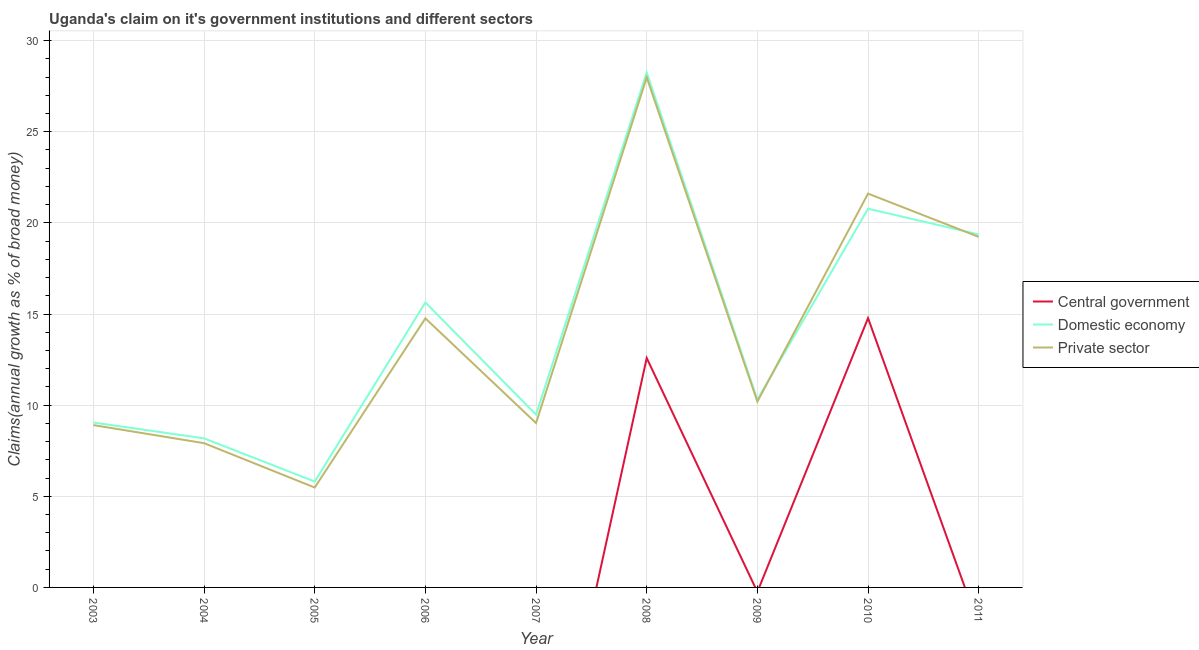Does the line corresponding to percentage of claim on the central government intersect with the line corresponding to percentage of claim on the private sector?
Your answer should be very brief. No. Is the number of lines equal to the number of legend labels?
Keep it short and to the point. No. What is the percentage of claim on the central government in 2005?
Ensure brevity in your answer.  0. Across all years, what is the maximum percentage of claim on the private sector?
Make the answer very short. 27.98. What is the total percentage of claim on the private sector in the graph?
Provide a short and direct response. 125.1. What is the difference between the percentage of claim on the domestic economy in 2007 and that in 2009?
Offer a terse response. -0.82. What is the difference between the percentage of claim on the domestic economy in 2007 and the percentage of claim on the central government in 2008?
Offer a very short reply. -3.1. What is the average percentage of claim on the private sector per year?
Offer a very short reply. 13.9. In the year 2003, what is the difference between the percentage of claim on the private sector and percentage of claim on the domestic economy?
Ensure brevity in your answer.  -0.14. In how many years, is the percentage of claim on the domestic economy greater than 7 %?
Provide a short and direct response. 8. What is the ratio of the percentage of claim on the private sector in 2004 to that in 2009?
Provide a short and direct response. 0.78. Is the percentage of claim on the private sector in 2003 less than that in 2011?
Offer a very short reply. Yes. Is the difference between the percentage of claim on the private sector in 2005 and 2008 greater than the difference between the percentage of claim on the domestic economy in 2005 and 2008?
Your response must be concise. No. What is the difference between the highest and the second highest percentage of claim on the private sector?
Provide a succinct answer. 6.38. What is the difference between the highest and the lowest percentage of claim on the domestic economy?
Give a very brief answer. 22.44. Is the sum of the percentage of claim on the domestic economy in 2005 and 2008 greater than the maximum percentage of claim on the central government across all years?
Provide a short and direct response. Yes. Does the percentage of claim on the private sector monotonically increase over the years?
Offer a terse response. No. Is the percentage of claim on the domestic economy strictly greater than the percentage of claim on the private sector over the years?
Offer a very short reply. No. Is the percentage of claim on the private sector strictly less than the percentage of claim on the domestic economy over the years?
Provide a succinct answer. No. How many lines are there?
Keep it short and to the point. 3. How many years are there in the graph?
Provide a short and direct response. 9. How are the legend labels stacked?
Give a very brief answer. Vertical. What is the title of the graph?
Provide a succinct answer. Uganda's claim on it's government institutions and different sectors. Does "Poland" appear as one of the legend labels in the graph?
Your response must be concise. No. What is the label or title of the X-axis?
Make the answer very short. Year. What is the label or title of the Y-axis?
Offer a terse response. Claims(annual growth as % of broad money). What is the Claims(annual growth as % of broad money) of Central government in 2003?
Your response must be concise. 0. What is the Claims(annual growth as % of broad money) of Domestic economy in 2003?
Provide a succinct answer. 9.05. What is the Claims(annual growth as % of broad money) in Private sector in 2003?
Give a very brief answer. 8.91. What is the Claims(annual growth as % of broad money) in Central government in 2004?
Make the answer very short. 0. What is the Claims(annual growth as % of broad money) of Domestic economy in 2004?
Offer a terse response. 8.18. What is the Claims(annual growth as % of broad money) of Private sector in 2004?
Provide a short and direct response. 7.91. What is the Claims(annual growth as % of broad money) in Central government in 2005?
Your answer should be compact. 0. What is the Claims(annual growth as % of broad money) in Domestic economy in 2005?
Your answer should be very brief. 5.81. What is the Claims(annual growth as % of broad money) of Private sector in 2005?
Give a very brief answer. 5.48. What is the Claims(annual growth as % of broad money) of Domestic economy in 2006?
Offer a terse response. 15.63. What is the Claims(annual growth as % of broad money) of Private sector in 2006?
Give a very brief answer. 14.76. What is the Claims(annual growth as % of broad money) of Domestic economy in 2007?
Give a very brief answer. 9.48. What is the Claims(annual growth as % of broad money) of Private sector in 2007?
Make the answer very short. 9.02. What is the Claims(annual growth as % of broad money) of Central government in 2008?
Make the answer very short. 12.59. What is the Claims(annual growth as % of broad money) in Domestic economy in 2008?
Provide a succinct answer. 28.25. What is the Claims(annual growth as % of broad money) in Private sector in 2008?
Give a very brief answer. 27.98. What is the Claims(annual growth as % of broad money) of Domestic economy in 2009?
Your answer should be compact. 10.31. What is the Claims(annual growth as % of broad money) of Private sector in 2009?
Make the answer very short. 10.2. What is the Claims(annual growth as % of broad money) in Central government in 2010?
Your response must be concise. 14.78. What is the Claims(annual growth as % of broad money) in Domestic economy in 2010?
Give a very brief answer. 20.78. What is the Claims(annual growth as % of broad money) in Private sector in 2010?
Your answer should be very brief. 21.61. What is the Claims(annual growth as % of broad money) of Domestic economy in 2011?
Make the answer very short. 19.37. What is the Claims(annual growth as % of broad money) in Private sector in 2011?
Give a very brief answer. 19.23. Across all years, what is the maximum Claims(annual growth as % of broad money) in Central government?
Provide a succinct answer. 14.78. Across all years, what is the maximum Claims(annual growth as % of broad money) in Domestic economy?
Your answer should be compact. 28.25. Across all years, what is the maximum Claims(annual growth as % of broad money) of Private sector?
Offer a very short reply. 27.98. Across all years, what is the minimum Claims(annual growth as % of broad money) in Domestic economy?
Provide a short and direct response. 5.81. Across all years, what is the minimum Claims(annual growth as % of broad money) of Private sector?
Your response must be concise. 5.48. What is the total Claims(annual growth as % of broad money) in Central government in the graph?
Ensure brevity in your answer.  27.36. What is the total Claims(annual growth as % of broad money) of Domestic economy in the graph?
Offer a very short reply. 126.85. What is the total Claims(annual growth as % of broad money) of Private sector in the graph?
Provide a short and direct response. 125.1. What is the difference between the Claims(annual growth as % of broad money) of Domestic economy in 2003 and that in 2004?
Give a very brief answer. 0.87. What is the difference between the Claims(annual growth as % of broad money) in Private sector in 2003 and that in 2004?
Offer a terse response. 0.99. What is the difference between the Claims(annual growth as % of broad money) of Domestic economy in 2003 and that in 2005?
Your answer should be very brief. 3.24. What is the difference between the Claims(annual growth as % of broad money) in Private sector in 2003 and that in 2005?
Provide a short and direct response. 3.43. What is the difference between the Claims(annual growth as % of broad money) of Domestic economy in 2003 and that in 2006?
Your response must be concise. -6.59. What is the difference between the Claims(annual growth as % of broad money) of Private sector in 2003 and that in 2006?
Your answer should be very brief. -5.86. What is the difference between the Claims(annual growth as % of broad money) of Domestic economy in 2003 and that in 2007?
Give a very brief answer. -0.43. What is the difference between the Claims(annual growth as % of broad money) of Private sector in 2003 and that in 2007?
Your answer should be very brief. -0.11. What is the difference between the Claims(annual growth as % of broad money) of Domestic economy in 2003 and that in 2008?
Offer a terse response. -19.2. What is the difference between the Claims(annual growth as % of broad money) of Private sector in 2003 and that in 2008?
Your answer should be very brief. -19.08. What is the difference between the Claims(annual growth as % of broad money) of Domestic economy in 2003 and that in 2009?
Keep it short and to the point. -1.26. What is the difference between the Claims(annual growth as % of broad money) of Private sector in 2003 and that in 2009?
Provide a succinct answer. -1.29. What is the difference between the Claims(annual growth as % of broad money) of Domestic economy in 2003 and that in 2010?
Ensure brevity in your answer.  -11.73. What is the difference between the Claims(annual growth as % of broad money) in Private sector in 2003 and that in 2010?
Keep it short and to the point. -12.7. What is the difference between the Claims(annual growth as % of broad money) of Domestic economy in 2003 and that in 2011?
Provide a short and direct response. -10.32. What is the difference between the Claims(annual growth as % of broad money) of Private sector in 2003 and that in 2011?
Offer a terse response. -10.33. What is the difference between the Claims(annual growth as % of broad money) in Domestic economy in 2004 and that in 2005?
Offer a very short reply. 2.37. What is the difference between the Claims(annual growth as % of broad money) in Private sector in 2004 and that in 2005?
Provide a short and direct response. 2.43. What is the difference between the Claims(annual growth as % of broad money) of Domestic economy in 2004 and that in 2006?
Provide a succinct answer. -7.45. What is the difference between the Claims(annual growth as % of broad money) of Private sector in 2004 and that in 2006?
Your answer should be compact. -6.85. What is the difference between the Claims(annual growth as % of broad money) in Domestic economy in 2004 and that in 2007?
Provide a succinct answer. -1.3. What is the difference between the Claims(annual growth as % of broad money) of Private sector in 2004 and that in 2007?
Give a very brief answer. -1.1. What is the difference between the Claims(annual growth as % of broad money) of Domestic economy in 2004 and that in 2008?
Give a very brief answer. -20.07. What is the difference between the Claims(annual growth as % of broad money) of Private sector in 2004 and that in 2008?
Ensure brevity in your answer.  -20.07. What is the difference between the Claims(annual growth as % of broad money) in Domestic economy in 2004 and that in 2009?
Your response must be concise. -2.13. What is the difference between the Claims(annual growth as % of broad money) of Private sector in 2004 and that in 2009?
Give a very brief answer. -2.28. What is the difference between the Claims(annual growth as % of broad money) in Domestic economy in 2004 and that in 2010?
Keep it short and to the point. -12.6. What is the difference between the Claims(annual growth as % of broad money) in Private sector in 2004 and that in 2010?
Keep it short and to the point. -13.69. What is the difference between the Claims(annual growth as % of broad money) in Domestic economy in 2004 and that in 2011?
Your answer should be very brief. -11.19. What is the difference between the Claims(annual growth as % of broad money) in Private sector in 2004 and that in 2011?
Make the answer very short. -11.32. What is the difference between the Claims(annual growth as % of broad money) in Domestic economy in 2005 and that in 2006?
Provide a short and direct response. -9.82. What is the difference between the Claims(annual growth as % of broad money) of Private sector in 2005 and that in 2006?
Ensure brevity in your answer.  -9.28. What is the difference between the Claims(annual growth as % of broad money) of Domestic economy in 2005 and that in 2007?
Offer a terse response. -3.67. What is the difference between the Claims(annual growth as % of broad money) in Private sector in 2005 and that in 2007?
Make the answer very short. -3.54. What is the difference between the Claims(annual growth as % of broad money) in Domestic economy in 2005 and that in 2008?
Your response must be concise. -22.44. What is the difference between the Claims(annual growth as % of broad money) in Private sector in 2005 and that in 2008?
Offer a terse response. -22.5. What is the difference between the Claims(annual growth as % of broad money) of Domestic economy in 2005 and that in 2009?
Ensure brevity in your answer.  -4.5. What is the difference between the Claims(annual growth as % of broad money) of Private sector in 2005 and that in 2009?
Your response must be concise. -4.71. What is the difference between the Claims(annual growth as % of broad money) in Domestic economy in 2005 and that in 2010?
Ensure brevity in your answer.  -14.97. What is the difference between the Claims(annual growth as % of broad money) in Private sector in 2005 and that in 2010?
Provide a succinct answer. -16.13. What is the difference between the Claims(annual growth as % of broad money) of Domestic economy in 2005 and that in 2011?
Provide a short and direct response. -13.56. What is the difference between the Claims(annual growth as % of broad money) of Private sector in 2005 and that in 2011?
Give a very brief answer. -13.75. What is the difference between the Claims(annual growth as % of broad money) in Domestic economy in 2006 and that in 2007?
Ensure brevity in your answer.  6.15. What is the difference between the Claims(annual growth as % of broad money) of Private sector in 2006 and that in 2007?
Your response must be concise. 5.75. What is the difference between the Claims(annual growth as % of broad money) in Domestic economy in 2006 and that in 2008?
Make the answer very short. -12.61. What is the difference between the Claims(annual growth as % of broad money) of Private sector in 2006 and that in 2008?
Give a very brief answer. -13.22. What is the difference between the Claims(annual growth as % of broad money) in Domestic economy in 2006 and that in 2009?
Provide a short and direct response. 5.33. What is the difference between the Claims(annual growth as % of broad money) in Private sector in 2006 and that in 2009?
Offer a terse response. 4.57. What is the difference between the Claims(annual growth as % of broad money) of Domestic economy in 2006 and that in 2010?
Give a very brief answer. -5.14. What is the difference between the Claims(annual growth as % of broad money) in Private sector in 2006 and that in 2010?
Offer a terse response. -6.84. What is the difference between the Claims(annual growth as % of broad money) in Domestic economy in 2006 and that in 2011?
Provide a succinct answer. -3.73. What is the difference between the Claims(annual growth as % of broad money) of Private sector in 2006 and that in 2011?
Keep it short and to the point. -4.47. What is the difference between the Claims(annual growth as % of broad money) of Domestic economy in 2007 and that in 2008?
Ensure brevity in your answer.  -18.76. What is the difference between the Claims(annual growth as % of broad money) of Private sector in 2007 and that in 2008?
Offer a very short reply. -18.97. What is the difference between the Claims(annual growth as % of broad money) in Domestic economy in 2007 and that in 2009?
Your response must be concise. -0.82. What is the difference between the Claims(annual growth as % of broad money) of Private sector in 2007 and that in 2009?
Your answer should be compact. -1.18. What is the difference between the Claims(annual growth as % of broad money) in Domestic economy in 2007 and that in 2010?
Your answer should be very brief. -11.3. What is the difference between the Claims(annual growth as % of broad money) in Private sector in 2007 and that in 2010?
Ensure brevity in your answer.  -12.59. What is the difference between the Claims(annual growth as % of broad money) of Domestic economy in 2007 and that in 2011?
Your answer should be compact. -9.89. What is the difference between the Claims(annual growth as % of broad money) in Private sector in 2007 and that in 2011?
Provide a succinct answer. -10.22. What is the difference between the Claims(annual growth as % of broad money) of Domestic economy in 2008 and that in 2009?
Keep it short and to the point. 17.94. What is the difference between the Claims(annual growth as % of broad money) of Private sector in 2008 and that in 2009?
Offer a very short reply. 17.79. What is the difference between the Claims(annual growth as % of broad money) in Central government in 2008 and that in 2010?
Your response must be concise. -2.19. What is the difference between the Claims(annual growth as % of broad money) in Domestic economy in 2008 and that in 2010?
Give a very brief answer. 7.47. What is the difference between the Claims(annual growth as % of broad money) of Private sector in 2008 and that in 2010?
Provide a short and direct response. 6.38. What is the difference between the Claims(annual growth as % of broad money) of Domestic economy in 2008 and that in 2011?
Your response must be concise. 8.88. What is the difference between the Claims(annual growth as % of broad money) in Private sector in 2008 and that in 2011?
Keep it short and to the point. 8.75. What is the difference between the Claims(annual growth as % of broad money) of Domestic economy in 2009 and that in 2010?
Your answer should be very brief. -10.47. What is the difference between the Claims(annual growth as % of broad money) in Private sector in 2009 and that in 2010?
Ensure brevity in your answer.  -11.41. What is the difference between the Claims(annual growth as % of broad money) of Domestic economy in 2009 and that in 2011?
Give a very brief answer. -9.06. What is the difference between the Claims(annual growth as % of broad money) in Private sector in 2009 and that in 2011?
Give a very brief answer. -9.04. What is the difference between the Claims(annual growth as % of broad money) in Domestic economy in 2010 and that in 2011?
Provide a succinct answer. 1.41. What is the difference between the Claims(annual growth as % of broad money) of Private sector in 2010 and that in 2011?
Your answer should be very brief. 2.37. What is the difference between the Claims(annual growth as % of broad money) of Domestic economy in 2003 and the Claims(annual growth as % of broad money) of Private sector in 2004?
Give a very brief answer. 1.13. What is the difference between the Claims(annual growth as % of broad money) in Domestic economy in 2003 and the Claims(annual growth as % of broad money) in Private sector in 2005?
Offer a terse response. 3.57. What is the difference between the Claims(annual growth as % of broad money) in Domestic economy in 2003 and the Claims(annual growth as % of broad money) in Private sector in 2006?
Offer a terse response. -5.72. What is the difference between the Claims(annual growth as % of broad money) of Domestic economy in 2003 and the Claims(annual growth as % of broad money) of Private sector in 2007?
Provide a succinct answer. 0.03. What is the difference between the Claims(annual growth as % of broad money) of Domestic economy in 2003 and the Claims(annual growth as % of broad money) of Private sector in 2008?
Offer a very short reply. -18.94. What is the difference between the Claims(annual growth as % of broad money) of Domestic economy in 2003 and the Claims(annual growth as % of broad money) of Private sector in 2009?
Offer a very short reply. -1.15. What is the difference between the Claims(annual growth as % of broad money) of Domestic economy in 2003 and the Claims(annual growth as % of broad money) of Private sector in 2010?
Provide a short and direct response. -12.56. What is the difference between the Claims(annual growth as % of broad money) in Domestic economy in 2003 and the Claims(annual growth as % of broad money) in Private sector in 2011?
Ensure brevity in your answer.  -10.19. What is the difference between the Claims(annual growth as % of broad money) of Domestic economy in 2004 and the Claims(annual growth as % of broad money) of Private sector in 2005?
Your answer should be very brief. 2.7. What is the difference between the Claims(annual growth as % of broad money) of Domestic economy in 2004 and the Claims(annual growth as % of broad money) of Private sector in 2006?
Your answer should be compact. -6.58. What is the difference between the Claims(annual growth as % of broad money) of Domestic economy in 2004 and the Claims(annual growth as % of broad money) of Private sector in 2007?
Your answer should be very brief. -0.84. What is the difference between the Claims(annual growth as % of broad money) in Domestic economy in 2004 and the Claims(annual growth as % of broad money) in Private sector in 2008?
Your answer should be very brief. -19.8. What is the difference between the Claims(annual growth as % of broad money) in Domestic economy in 2004 and the Claims(annual growth as % of broad money) in Private sector in 2009?
Your response must be concise. -2.01. What is the difference between the Claims(annual growth as % of broad money) of Domestic economy in 2004 and the Claims(annual growth as % of broad money) of Private sector in 2010?
Your answer should be compact. -13.43. What is the difference between the Claims(annual growth as % of broad money) in Domestic economy in 2004 and the Claims(annual growth as % of broad money) in Private sector in 2011?
Your answer should be compact. -11.05. What is the difference between the Claims(annual growth as % of broad money) of Domestic economy in 2005 and the Claims(annual growth as % of broad money) of Private sector in 2006?
Offer a very short reply. -8.95. What is the difference between the Claims(annual growth as % of broad money) in Domestic economy in 2005 and the Claims(annual growth as % of broad money) in Private sector in 2007?
Give a very brief answer. -3.21. What is the difference between the Claims(annual growth as % of broad money) in Domestic economy in 2005 and the Claims(annual growth as % of broad money) in Private sector in 2008?
Make the answer very short. -22.17. What is the difference between the Claims(annual growth as % of broad money) of Domestic economy in 2005 and the Claims(annual growth as % of broad money) of Private sector in 2009?
Your response must be concise. -4.38. What is the difference between the Claims(annual growth as % of broad money) of Domestic economy in 2005 and the Claims(annual growth as % of broad money) of Private sector in 2010?
Keep it short and to the point. -15.8. What is the difference between the Claims(annual growth as % of broad money) of Domestic economy in 2005 and the Claims(annual growth as % of broad money) of Private sector in 2011?
Your response must be concise. -13.42. What is the difference between the Claims(annual growth as % of broad money) of Domestic economy in 2006 and the Claims(annual growth as % of broad money) of Private sector in 2007?
Offer a very short reply. 6.62. What is the difference between the Claims(annual growth as % of broad money) of Domestic economy in 2006 and the Claims(annual growth as % of broad money) of Private sector in 2008?
Keep it short and to the point. -12.35. What is the difference between the Claims(annual growth as % of broad money) in Domestic economy in 2006 and the Claims(annual growth as % of broad money) in Private sector in 2009?
Keep it short and to the point. 5.44. What is the difference between the Claims(annual growth as % of broad money) in Domestic economy in 2006 and the Claims(annual growth as % of broad money) in Private sector in 2010?
Offer a very short reply. -5.97. What is the difference between the Claims(annual growth as % of broad money) in Domestic economy in 2006 and the Claims(annual growth as % of broad money) in Private sector in 2011?
Offer a terse response. -3.6. What is the difference between the Claims(annual growth as % of broad money) in Domestic economy in 2007 and the Claims(annual growth as % of broad money) in Private sector in 2008?
Offer a terse response. -18.5. What is the difference between the Claims(annual growth as % of broad money) of Domestic economy in 2007 and the Claims(annual growth as % of broad money) of Private sector in 2009?
Offer a terse response. -0.71. What is the difference between the Claims(annual growth as % of broad money) in Domestic economy in 2007 and the Claims(annual growth as % of broad money) in Private sector in 2010?
Provide a short and direct response. -12.13. What is the difference between the Claims(annual growth as % of broad money) in Domestic economy in 2007 and the Claims(annual growth as % of broad money) in Private sector in 2011?
Give a very brief answer. -9.75. What is the difference between the Claims(annual growth as % of broad money) in Central government in 2008 and the Claims(annual growth as % of broad money) in Domestic economy in 2009?
Your response must be concise. 2.28. What is the difference between the Claims(annual growth as % of broad money) in Central government in 2008 and the Claims(annual growth as % of broad money) in Private sector in 2009?
Offer a very short reply. 2.39. What is the difference between the Claims(annual growth as % of broad money) in Domestic economy in 2008 and the Claims(annual growth as % of broad money) in Private sector in 2009?
Provide a short and direct response. 18.05. What is the difference between the Claims(annual growth as % of broad money) of Central government in 2008 and the Claims(annual growth as % of broad money) of Domestic economy in 2010?
Provide a short and direct response. -8.19. What is the difference between the Claims(annual growth as % of broad money) in Central government in 2008 and the Claims(annual growth as % of broad money) in Private sector in 2010?
Your answer should be very brief. -9.02. What is the difference between the Claims(annual growth as % of broad money) in Domestic economy in 2008 and the Claims(annual growth as % of broad money) in Private sector in 2010?
Make the answer very short. 6.64. What is the difference between the Claims(annual growth as % of broad money) in Central government in 2008 and the Claims(annual growth as % of broad money) in Domestic economy in 2011?
Give a very brief answer. -6.78. What is the difference between the Claims(annual growth as % of broad money) in Central government in 2008 and the Claims(annual growth as % of broad money) in Private sector in 2011?
Ensure brevity in your answer.  -6.65. What is the difference between the Claims(annual growth as % of broad money) in Domestic economy in 2008 and the Claims(annual growth as % of broad money) in Private sector in 2011?
Offer a very short reply. 9.01. What is the difference between the Claims(annual growth as % of broad money) of Domestic economy in 2009 and the Claims(annual growth as % of broad money) of Private sector in 2010?
Your response must be concise. -11.3. What is the difference between the Claims(annual growth as % of broad money) in Domestic economy in 2009 and the Claims(annual growth as % of broad money) in Private sector in 2011?
Provide a short and direct response. -8.93. What is the difference between the Claims(annual growth as % of broad money) of Central government in 2010 and the Claims(annual growth as % of broad money) of Domestic economy in 2011?
Offer a very short reply. -4.59. What is the difference between the Claims(annual growth as % of broad money) in Central government in 2010 and the Claims(annual growth as % of broad money) in Private sector in 2011?
Your answer should be compact. -4.46. What is the difference between the Claims(annual growth as % of broad money) of Domestic economy in 2010 and the Claims(annual growth as % of broad money) of Private sector in 2011?
Offer a very short reply. 1.55. What is the average Claims(annual growth as % of broad money) of Central government per year?
Make the answer very short. 3.04. What is the average Claims(annual growth as % of broad money) in Domestic economy per year?
Your answer should be compact. 14.09. What is the average Claims(annual growth as % of broad money) in Private sector per year?
Make the answer very short. 13.9. In the year 2003, what is the difference between the Claims(annual growth as % of broad money) of Domestic economy and Claims(annual growth as % of broad money) of Private sector?
Your response must be concise. 0.14. In the year 2004, what is the difference between the Claims(annual growth as % of broad money) of Domestic economy and Claims(annual growth as % of broad money) of Private sector?
Offer a very short reply. 0.27. In the year 2005, what is the difference between the Claims(annual growth as % of broad money) of Domestic economy and Claims(annual growth as % of broad money) of Private sector?
Provide a short and direct response. 0.33. In the year 2006, what is the difference between the Claims(annual growth as % of broad money) of Domestic economy and Claims(annual growth as % of broad money) of Private sector?
Provide a short and direct response. 0.87. In the year 2007, what is the difference between the Claims(annual growth as % of broad money) in Domestic economy and Claims(annual growth as % of broad money) in Private sector?
Keep it short and to the point. 0.46. In the year 2008, what is the difference between the Claims(annual growth as % of broad money) in Central government and Claims(annual growth as % of broad money) in Domestic economy?
Offer a very short reply. -15.66. In the year 2008, what is the difference between the Claims(annual growth as % of broad money) in Central government and Claims(annual growth as % of broad money) in Private sector?
Ensure brevity in your answer.  -15.4. In the year 2008, what is the difference between the Claims(annual growth as % of broad money) of Domestic economy and Claims(annual growth as % of broad money) of Private sector?
Your answer should be very brief. 0.26. In the year 2009, what is the difference between the Claims(annual growth as % of broad money) of Domestic economy and Claims(annual growth as % of broad money) of Private sector?
Your response must be concise. 0.11. In the year 2010, what is the difference between the Claims(annual growth as % of broad money) in Central government and Claims(annual growth as % of broad money) in Domestic economy?
Your answer should be compact. -6. In the year 2010, what is the difference between the Claims(annual growth as % of broad money) of Central government and Claims(annual growth as % of broad money) of Private sector?
Offer a very short reply. -6.83. In the year 2010, what is the difference between the Claims(annual growth as % of broad money) of Domestic economy and Claims(annual growth as % of broad money) of Private sector?
Make the answer very short. -0.83. In the year 2011, what is the difference between the Claims(annual growth as % of broad money) in Domestic economy and Claims(annual growth as % of broad money) in Private sector?
Make the answer very short. 0.13. What is the ratio of the Claims(annual growth as % of broad money) of Domestic economy in 2003 to that in 2004?
Offer a very short reply. 1.11. What is the ratio of the Claims(annual growth as % of broad money) of Private sector in 2003 to that in 2004?
Make the answer very short. 1.13. What is the ratio of the Claims(annual growth as % of broad money) in Domestic economy in 2003 to that in 2005?
Your answer should be very brief. 1.56. What is the ratio of the Claims(annual growth as % of broad money) in Private sector in 2003 to that in 2005?
Provide a succinct answer. 1.62. What is the ratio of the Claims(annual growth as % of broad money) of Domestic economy in 2003 to that in 2006?
Make the answer very short. 0.58. What is the ratio of the Claims(annual growth as % of broad money) in Private sector in 2003 to that in 2006?
Your answer should be very brief. 0.6. What is the ratio of the Claims(annual growth as % of broad money) in Domestic economy in 2003 to that in 2007?
Offer a very short reply. 0.95. What is the ratio of the Claims(annual growth as % of broad money) in Private sector in 2003 to that in 2007?
Your answer should be compact. 0.99. What is the ratio of the Claims(annual growth as % of broad money) in Domestic economy in 2003 to that in 2008?
Offer a terse response. 0.32. What is the ratio of the Claims(annual growth as % of broad money) in Private sector in 2003 to that in 2008?
Keep it short and to the point. 0.32. What is the ratio of the Claims(annual growth as % of broad money) of Domestic economy in 2003 to that in 2009?
Ensure brevity in your answer.  0.88. What is the ratio of the Claims(annual growth as % of broad money) of Private sector in 2003 to that in 2009?
Your answer should be compact. 0.87. What is the ratio of the Claims(annual growth as % of broad money) of Domestic economy in 2003 to that in 2010?
Your response must be concise. 0.44. What is the ratio of the Claims(annual growth as % of broad money) of Private sector in 2003 to that in 2010?
Keep it short and to the point. 0.41. What is the ratio of the Claims(annual growth as % of broad money) of Domestic economy in 2003 to that in 2011?
Ensure brevity in your answer.  0.47. What is the ratio of the Claims(annual growth as % of broad money) of Private sector in 2003 to that in 2011?
Your answer should be compact. 0.46. What is the ratio of the Claims(annual growth as % of broad money) of Domestic economy in 2004 to that in 2005?
Ensure brevity in your answer.  1.41. What is the ratio of the Claims(annual growth as % of broad money) of Private sector in 2004 to that in 2005?
Give a very brief answer. 1.44. What is the ratio of the Claims(annual growth as % of broad money) of Domestic economy in 2004 to that in 2006?
Your answer should be compact. 0.52. What is the ratio of the Claims(annual growth as % of broad money) of Private sector in 2004 to that in 2006?
Your answer should be compact. 0.54. What is the ratio of the Claims(annual growth as % of broad money) in Domestic economy in 2004 to that in 2007?
Your answer should be very brief. 0.86. What is the ratio of the Claims(annual growth as % of broad money) of Private sector in 2004 to that in 2007?
Offer a terse response. 0.88. What is the ratio of the Claims(annual growth as % of broad money) in Domestic economy in 2004 to that in 2008?
Ensure brevity in your answer.  0.29. What is the ratio of the Claims(annual growth as % of broad money) of Private sector in 2004 to that in 2008?
Your response must be concise. 0.28. What is the ratio of the Claims(annual growth as % of broad money) of Domestic economy in 2004 to that in 2009?
Keep it short and to the point. 0.79. What is the ratio of the Claims(annual growth as % of broad money) in Private sector in 2004 to that in 2009?
Ensure brevity in your answer.  0.78. What is the ratio of the Claims(annual growth as % of broad money) of Domestic economy in 2004 to that in 2010?
Make the answer very short. 0.39. What is the ratio of the Claims(annual growth as % of broad money) of Private sector in 2004 to that in 2010?
Provide a succinct answer. 0.37. What is the ratio of the Claims(annual growth as % of broad money) in Domestic economy in 2004 to that in 2011?
Your response must be concise. 0.42. What is the ratio of the Claims(annual growth as % of broad money) in Private sector in 2004 to that in 2011?
Offer a terse response. 0.41. What is the ratio of the Claims(annual growth as % of broad money) in Domestic economy in 2005 to that in 2006?
Keep it short and to the point. 0.37. What is the ratio of the Claims(annual growth as % of broad money) in Private sector in 2005 to that in 2006?
Your answer should be very brief. 0.37. What is the ratio of the Claims(annual growth as % of broad money) of Domestic economy in 2005 to that in 2007?
Offer a terse response. 0.61. What is the ratio of the Claims(annual growth as % of broad money) of Private sector in 2005 to that in 2007?
Offer a very short reply. 0.61. What is the ratio of the Claims(annual growth as % of broad money) of Domestic economy in 2005 to that in 2008?
Ensure brevity in your answer.  0.21. What is the ratio of the Claims(annual growth as % of broad money) in Private sector in 2005 to that in 2008?
Your answer should be very brief. 0.2. What is the ratio of the Claims(annual growth as % of broad money) in Domestic economy in 2005 to that in 2009?
Offer a terse response. 0.56. What is the ratio of the Claims(annual growth as % of broad money) in Private sector in 2005 to that in 2009?
Make the answer very short. 0.54. What is the ratio of the Claims(annual growth as % of broad money) in Domestic economy in 2005 to that in 2010?
Offer a terse response. 0.28. What is the ratio of the Claims(annual growth as % of broad money) in Private sector in 2005 to that in 2010?
Your answer should be compact. 0.25. What is the ratio of the Claims(annual growth as % of broad money) of Domestic economy in 2005 to that in 2011?
Make the answer very short. 0.3. What is the ratio of the Claims(annual growth as % of broad money) in Private sector in 2005 to that in 2011?
Offer a terse response. 0.28. What is the ratio of the Claims(annual growth as % of broad money) of Domestic economy in 2006 to that in 2007?
Make the answer very short. 1.65. What is the ratio of the Claims(annual growth as % of broad money) of Private sector in 2006 to that in 2007?
Your answer should be compact. 1.64. What is the ratio of the Claims(annual growth as % of broad money) in Domestic economy in 2006 to that in 2008?
Your response must be concise. 0.55. What is the ratio of the Claims(annual growth as % of broad money) of Private sector in 2006 to that in 2008?
Give a very brief answer. 0.53. What is the ratio of the Claims(annual growth as % of broad money) in Domestic economy in 2006 to that in 2009?
Your answer should be very brief. 1.52. What is the ratio of the Claims(annual growth as % of broad money) of Private sector in 2006 to that in 2009?
Give a very brief answer. 1.45. What is the ratio of the Claims(annual growth as % of broad money) of Domestic economy in 2006 to that in 2010?
Your response must be concise. 0.75. What is the ratio of the Claims(annual growth as % of broad money) of Private sector in 2006 to that in 2010?
Ensure brevity in your answer.  0.68. What is the ratio of the Claims(annual growth as % of broad money) of Domestic economy in 2006 to that in 2011?
Your answer should be very brief. 0.81. What is the ratio of the Claims(annual growth as % of broad money) of Private sector in 2006 to that in 2011?
Offer a very short reply. 0.77. What is the ratio of the Claims(annual growth as % of broad money) in Domestic economy in 2007 to that in 2008?
Make the answer very short. 0.34. What is the ratio of the Claims(annual growth as % of broad money) in Private sector in 2007 to that in 2008?
Provide a succinct answer. 0.32. What is the ratio of the Claims(annual growth as % of broad money) in Private sector in 2007 to that in 2009?
Your answer should be compact. 0.88. What is the ratio of the Claims(annual growth as % of broad money) of Domestic economy in 2007 to that in 2010?
Give a very brief answer. 0.46. What is the ratio of the Claims(annual growth as % of broad money) in Private sector in 2007 to that in 2010?
Give a very brief answer. 0.42. What is the ratio of the Claims(annual growth as % of broad money) of Domestic economy in 2007 to that in 2011?
Your answer should be very brief. 0.49. What is the ratio of the Claims(annual growth as % of broad money) of Private sector in 2007 to that in 2011?
Your answer should be very brief. 0.47. What is the ratio of the Claims(annual growth as % of broad money) in Domestic economy in 2008 to that in 2009?
Ensure brevity in your answer.  2.74. What is the ratio of the Claims(annual growth as % of broad money) in Private sector in 2008 to that in 2009?
Provide a succinct answer. 2.74. What is the ratio of the Claims(annual growth as % of broad money) of Central government in 2008 to that in 2010?
Keep it short and to the point. 0.85. What is the ratio of the Claims(annual growth as % of broad money) of Domestic economy in 2008 to that in 2010?
Offer a very short reply. 1.36. What is the ratio of the Claims(annual growth as % of broad money) in Private sector in 2008 to that in 2010?
Your response must be concise. 1.3. What is the ratio of the Claims(annual growth as % of broad money) of Domestic economy in 2008 to that in 2011?
Your answer should be compact. 1.46. What is the ratio of the Claims(annual growth as % of broad money) in Private sector in 2008 to that in 2011?
Provide a short and direct response. 1.46. What is the ratio of the Claims(annual growth as % of broad money) in Domestic economy in 2009 to that in 2010?
Ensure brevity in your answer.  0.5. What is the ratio of the Claims(annual growth as % of broad money) in Private sector in 2009 to that in 2010?
Provide a short and direct response. 0.47. What is the ratio of the Claims(annual growth as % of broad money) in Domestic economy in 2009 to that in 2011?
Make the answer very short. 0.53. What is the ratio of the Claims(annual growth as % of broad money) of Private sector in 2009 to that in 2011?
Your answer should be very brief. 0.53. What is the ratio of the Claims(annual growth as % of broad money) of Domestic economy in 2010 to that in 2011?
Keep it short and to the point. 1.07. What is the ratio of the Claims(annual growth as % of broad money) of Private sector in 2010 to that in 2011?
Provide a succinct answer. 1.12. What is the difference between the highest and the second highest Claims(annual growth as % of broad money) in Domestic economy?
Provide a succinct answer. 7.47. What is the difference between the highest and the second highest Claims(annual growth as % of broad money) of Private sector?
Your answer should be compact. 6.38. What is the difference between the highest and the lowest Claims(annual growth as % of broad money) in Central government?
Your answer should be very brief. 14.78. What is the difference between the highest and the lowest Claims(annual growth as % of broad money) in Domestic economy?
Give a very brief answer. 22.44. What is the difference between the highest and the lowest Claims(annual growth as % of broad money) of Private sector?
Provide a succinct answer. 22.5. 